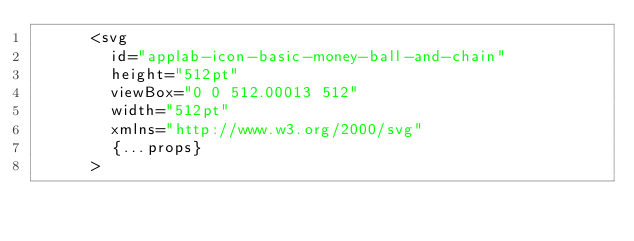Convert code to text. <code><loc_0><loc_0><loc_500><loc_500><_TypeScript_>      <svg
        id="applab-icon-basic-money-ball-and-chain"
        height="512pt"
        viewBox="0 0 512.00013 512"
        width="512pt"
        xmlns="http://www.w3.org/2000/svg"
        {...props}
      ></code> 